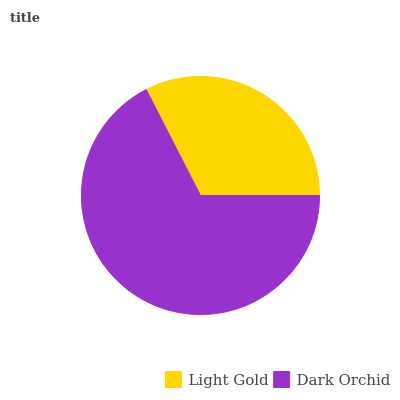Is Light Gold the minimum?
Answer yes or no. Yes. Is Dark Orchid the maximum?
Answer yes or no. Yes. Is Dark Orchid the minimum?
Answer yes or no. No. Is Dark Orchid greater than Light Gold?
Answer yes or no. Yes. Is Light Gold less than Dark Orchid?
Answer yes or no. Yes. Is Light Gold greater than Dark Orchid?
Answer yes or no. No. Is Dark Orchid less than Light Gold?
Answer yes or no. No. Is Dark Orchid the high median?
Answer yes or no. Yes. Is Light Gold the low median?
Answer yes or no. Yes. Is Light Gold the high median?
Answer yes or no. No. Is Dark Orchid the low median?
Answer yes or no. No. 